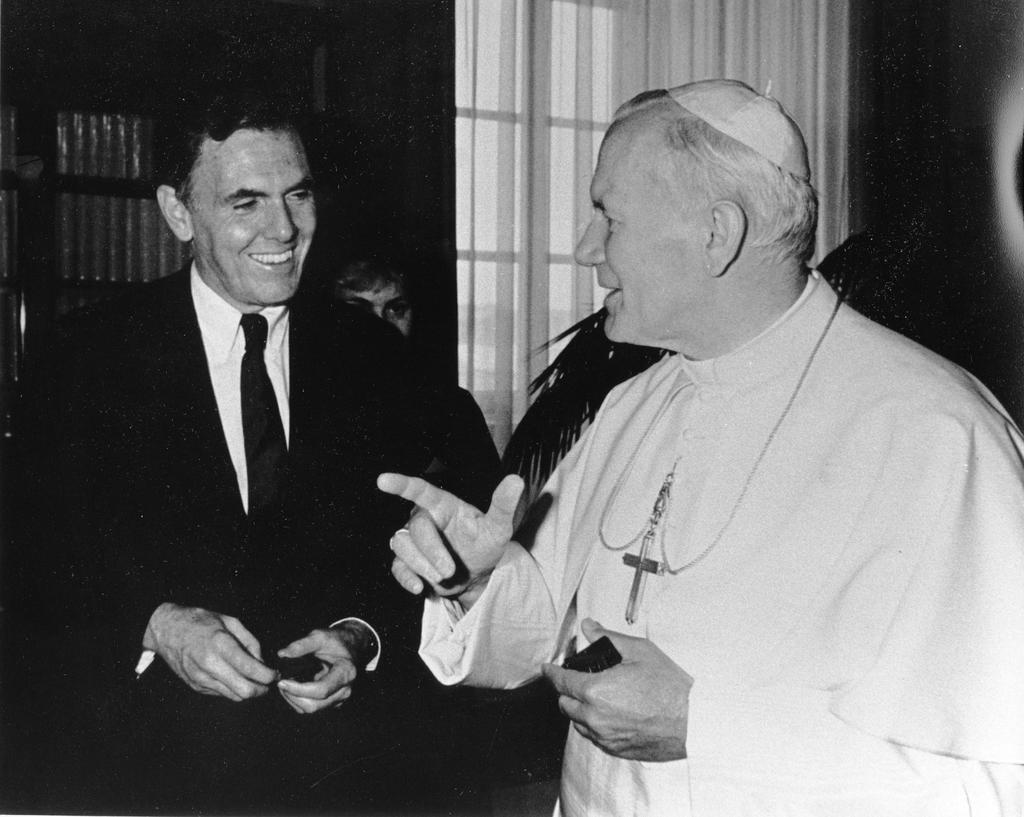How would you summarize this image in a sentence or two? As we can see the image is black and white picture where in front there are two men standing. The man on the left side is wearing a formal suit on the other side the man over here is wearing a long dress and there is a cross in his neck, he is wearing a small head cap. They both are looking at each other. 